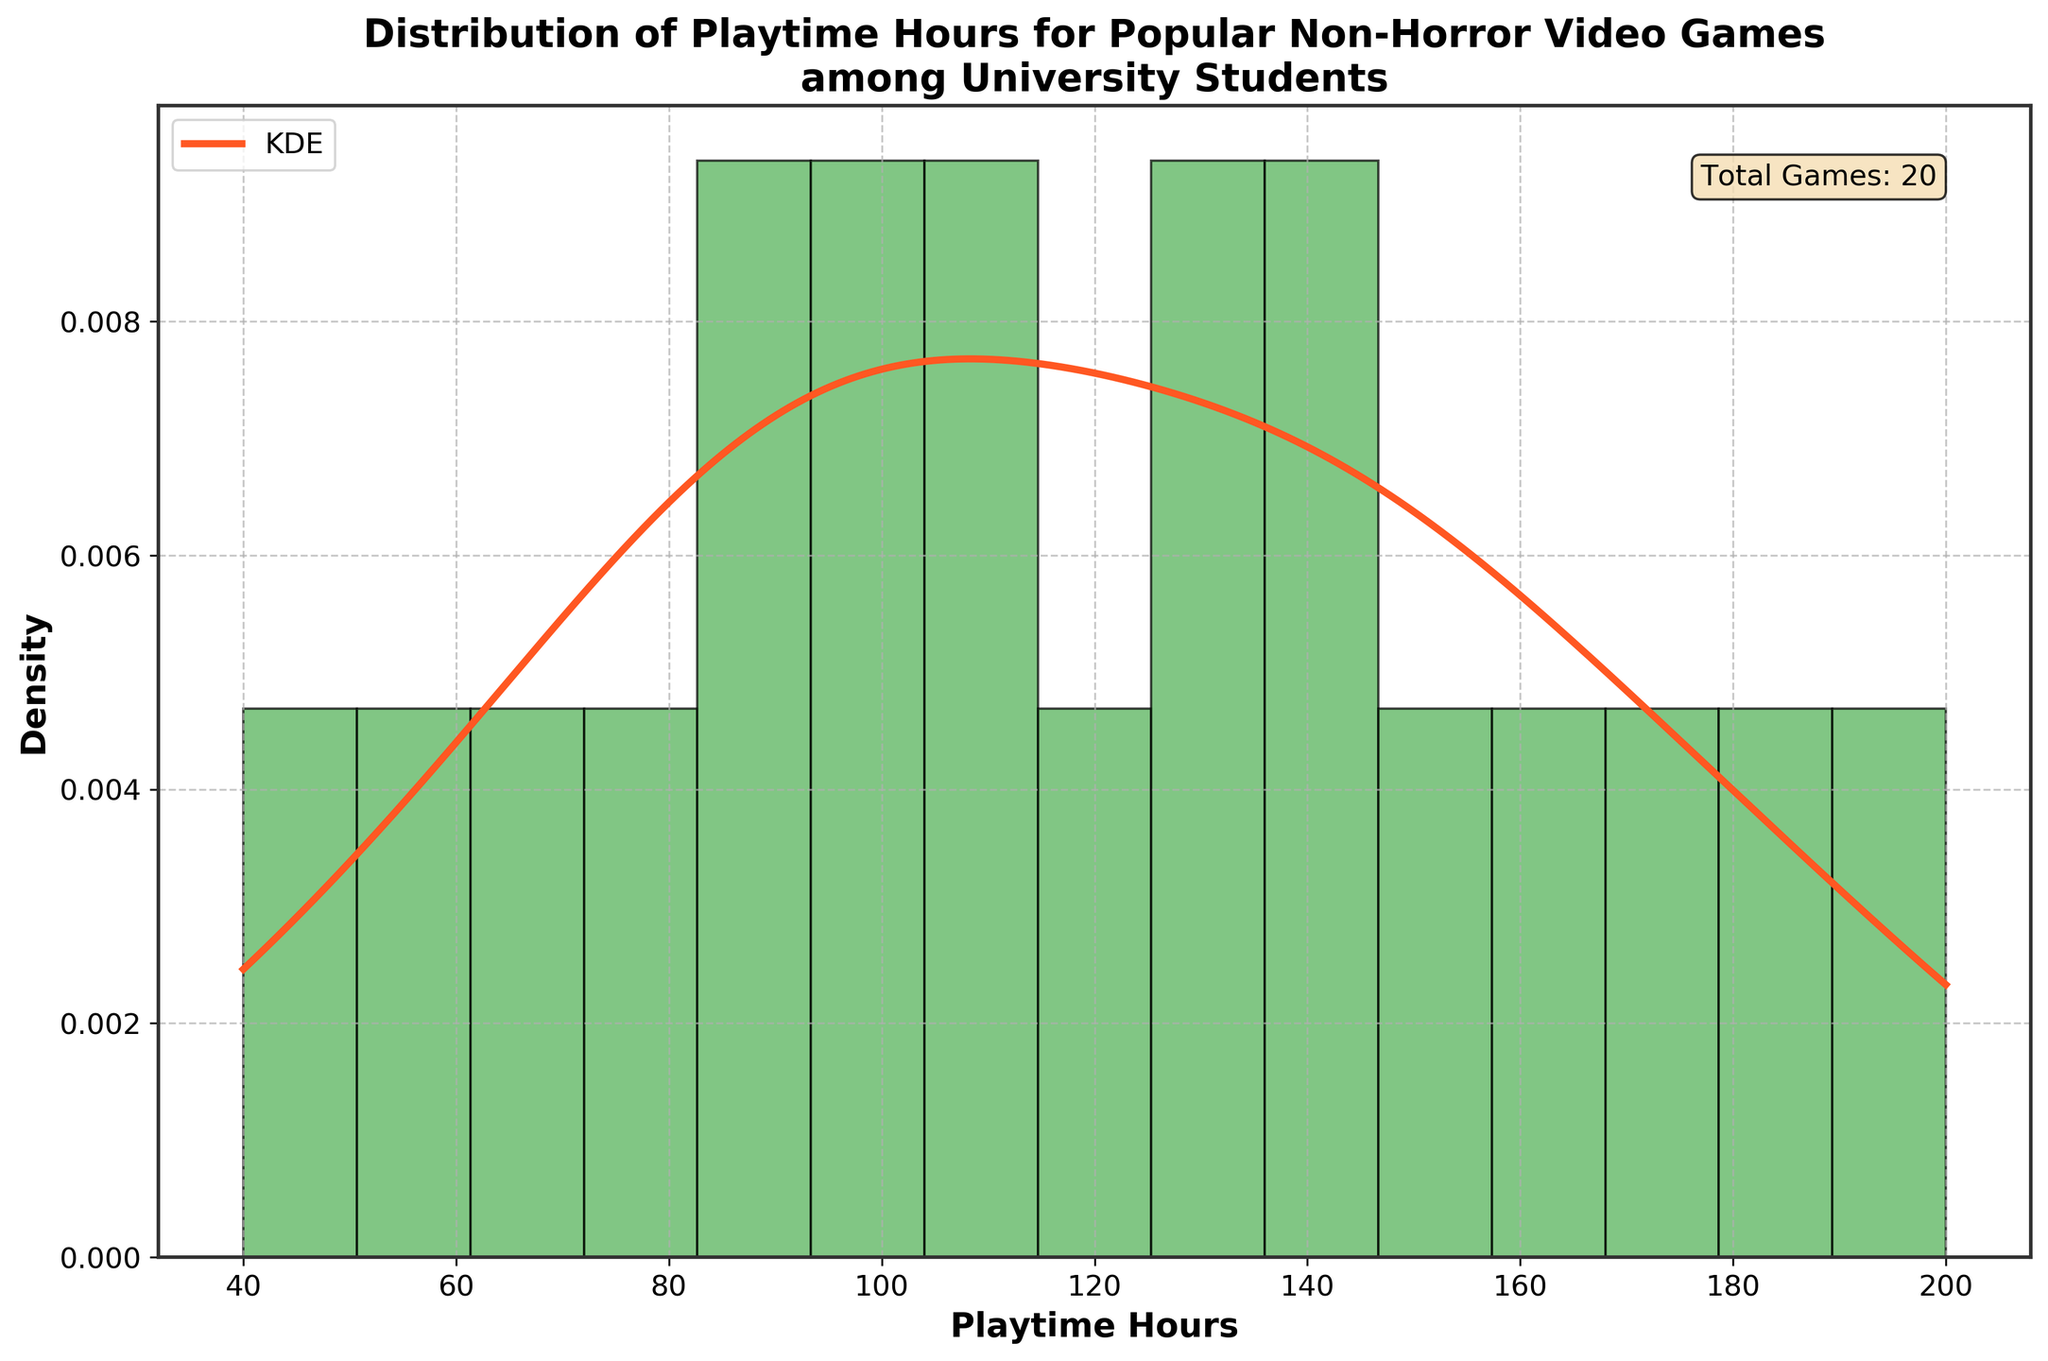Which game had the most playtime hours? The histogram shows multiple bars for playtime hours, but it is clear from reading the title that the data is about non-horror video games' playtime, and one game had the maximum number of playtime hours. By looking at the data or the densest/highest bar, we can find out Minecraft, with 200 hours, has the most playtime.
Answer: Minecraft How many games had a playtime of fewer than 50 hours? By examining the bins towards the left of the histogram, it is seen that the first bin includes playtime hours for fewer than 50 hours. According to the data table, there's only one game, Among Us, with 40 hours.
Answer: 1 What is the overall range of playtime hours shown in this distribution? To determine the range, find the minimum and maximum playtime hours in the data set. The minimum playtime is 40 hours (Among Us), and the maximum playtime is 200 hours (Minecraft), thus the range is 200 - 40.
Answer: 160 What does the KDE curve represent? The KDE curve smoothes out the frequency depicted by the histogram and provides a continuous probability density function over the playtime hours, indicating where the majority of the values lie.
Answer: Continuous probability density Are the playtime hours normally distributed based on the KDE curve? By observing the shape of the KDE curve, we can assess its symmetry. A normal distribution would typically show a bell curve, but in this histogram, the KDE curve appears to deviate, indicating that the distribution is not normal.
Answer: No What is the approximate mode of the playtime distribution? The mode is the value that appears most frequently. Based on the histogram and KDE curve's peak, we notice that the highest density occurs around 120-130 playtime hours.
Answer: 120-130 hours Which two games' playtimes combined exceed 300 hours? Summing the largest individual playtime values: Minecraft (200 hours) and Animal Crossing: New Horizons (180 hours), which together exceed 300 hours.
Answer: Minecraft and Animal Crossing: New Horizons How many games have a playtime of more than 150 hours? Referring to the data, the games with more than 150 hours are Stardew Valley (150), Animal Crossing: New Horizons (180), League of Legends (160), and The Sims 4 (175). Thus, 4 games fit this criteria.
Answer: 4 What is the median playtime value for these games? To find the median, sort the playtimes: [40, 55, 70, 80, 85, 90, 95, 100, 105, 110, 120, 130, 135, 140, 145, 150, 160, 175, 180, 200]. The median is the middle value of the sorted list, and since there are 20 values, the median is the average of the 10th (110) and 11th (120) values. Thus, (110+120)/2 = 115.
Answer: 115 hours 